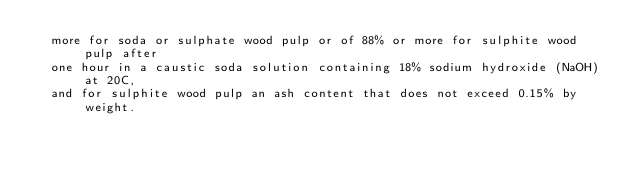<code> <loc_0><loc_0><loc_500><loc_500><_YAML_>  more for soda or sulphate wood pulp or of 88% or more for sulphite wood pulp after
  one hour in a caustic soda solution containing 18% sodium hydroxide (NaOH) at 20C,
  and for sulphite wood pulp an ash content that does not exceed 0.15% by weight.
</code> 